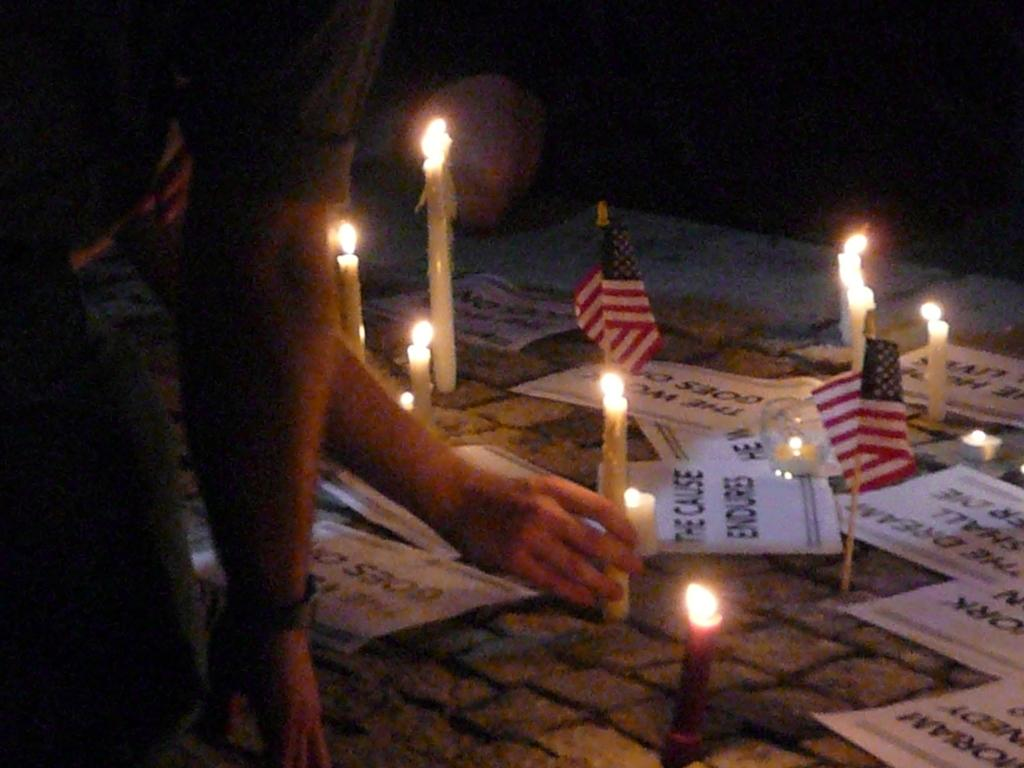What body parts are visible in the image? There are people's hands in the image. What objects are present that provide light? There are candles in the image. What items are related to a specific event or cause? There are flags in the image. What type of items are used for writing or documentation? There are papers in the image. What type of ball is being used as an apparatus in the image? There is no ball or apparatus present in the image. Is there a volcano visible in the image? No, there is no volcano present in the image. 